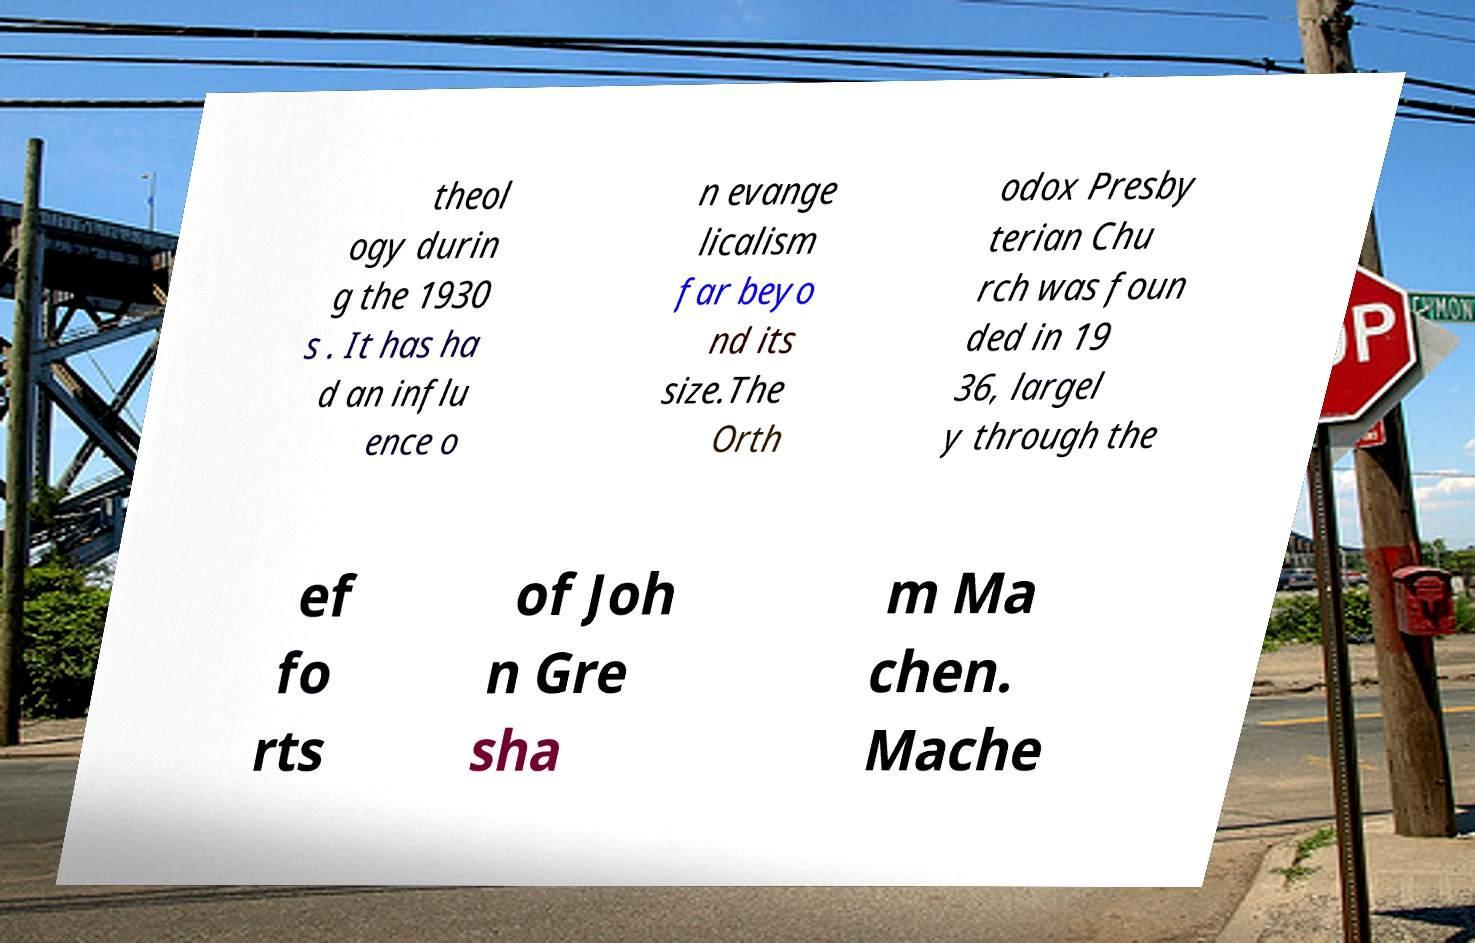Can you read and provide the text displayed in the image?This photo seems to have some interesting text. Can you extract and type it out for me? theol ogy durin g the 1930 s . It has ha d an influ ence o n evange licalism far beyo nd its size.The Orth odox Presby terian Chu rch was foun ded in 19 36, largel y through the ef fo rts of Joh n Gre sha m Ma chen. Mache 